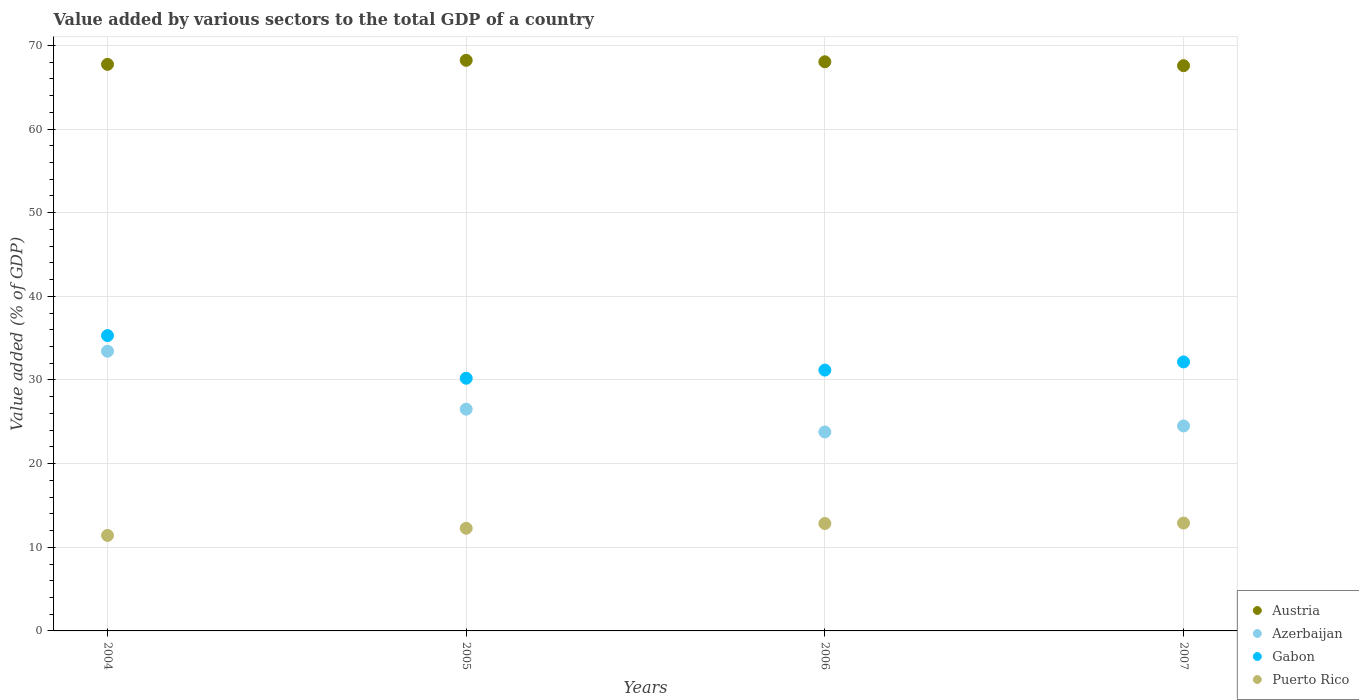How many different coloured dotlines are there?
Your response must be concise. 4. Is the number of dotlines equal to the number of legend labels?
Provide a succinct answer. Yes. What is the value added by various sectors to the total GDP in Azerbaijan in 2004?
Ensure brevity in your answer.  33.44. Across all years, what is the maximum value added by various sectors to the total GDP in Puerto Rico?
Keep it short and to the point. 12.9. Across all years, what is the minimum value added by various sectors to the total GDP in Puerto Rico?
Your answer should be compact. 11.42. What is the total value added by various sectors to the total GDP in Puerto Rico in the graph?
Offer a terse response. 49.43. What is the difference between the value added by various sectors to the total GDP in Puerto Rico in 2005 and that in 2007?
Keep it short and to the point. -0.62. What is the difference between the value added by various sectors to the total GDP in Azerbaijan in 2005 and the value added by various sectors to the total GDP in Gabon in 2007?
Your response must be concise. -5.65. What is the average value added by various sectors to the total GDP in Puerto Rico per year?
Keep it short and to the point. 12.36. In the year 2006, what is the difference between the value added by various sectors to the total GDP in Austria and value added by various sectors to the total GDP in Gabon?
Offer a very short reply. 36.86. In how many years, is the value added by various sectors to the total GDP in Puerto Rico greater than 62 %?
Offer a very short reply. 0. What is the ratio of the value added by various sectors to the total GDP in Austria in 2004 to that in 2006?
Keep it short and to the point. 1. Is the value added by various sectors to the total GDP in Azerbaijan in 2005 less than that in 2007?
Your response must be concise. No. Is the difference between the value added by various sectors to the total GDP in Austria in 2004 and 2007 greater than the difference between the value added by various sectors to the total GDP in Gabon in 2004 and 2007?
Keep it short and to the point. No. What is the difference between the highest and the second highest value added by various sectors to the total GDP in Austria?
Make the answer very short. 0.17. What is the difference between the highest and the lowest value added by various sectors to the total GDP in Azerbaijan?
Your answer should be compact. 9.65. Is it the case that in every year, the sum of the value added by various sectors to the total GDP in Puerto Rico and value added by various sectors to the total GDP in Azerbaijan  is greater than the value added by various sectors to the total GDP in Gabon?
Offer a very short reply. Yes. Does the value added by various sectors to the total GDP in Puerto Rico monotonically increase over the years?
Your response must be concise. Yes. How many dotlines are there?
Ensure brevity in your answer.  4. How many years are there in the graph?
Provide a short and direct response. 4. What is the difference between two consecutive major ticks on the Y-axis?
Ensure brevity in your answer.  10. Are the values on the major ticks of Y-axis written in scientific E-notation?
Provide a succinct answer. No. Does the graph contain any zero values?
Ensure brevity in your answer.  No. Where does the legend appear in the graph?
Provide a succinct answer. Bottom right. How are the legend labels stacked?
Give a very brief answer. Vertical. What is the title of the graph?
Ensure brevity in your answer.  Value added by various sectors to the total GDP of a country. What is the label or title of the X-axis?
Provide a short and direct response. Years. What is the label or title of the Y-axis?
Your answer should be compact. Value added (% of GDP). What is the Value added (% of GDP) in Austria in 2004?
Your response must be concise. 67.73. What is the Value added (% of GDP) in Azerbaijan in 2004?
Offer a very short reply. 33.44. What is the Value added (% of GDP) in Gabon in 2004?
Provide a succinct answer. 35.3. What is the Value added (% of GDP) in Puerto Rico in 2004?
Your response must be concise. 11.42. What is the Value added (% of GDP) of Austria in 2005?
Your answer should be compact. 68.21. What is the Value added (% of GDP) in Azerbaijan in 2005?
Provide a succinct answer. 26.51. What is the Value added (% of GDP) of Gabon in 2005?
Ensure brevity in your answer.  30.21. What is the Value added (% of GDP) in Puerto Rico in 2005?
Your answer should be very brief. 12.27. What is the Value added (% of GDP) of Austria in 2006?
Provide a short and direct response. 68.04. What is the Value added (% of GDP) of Azerbaijan in 2006?
Your answer should be compact. 23.79. What is the Value added (% of GDP) of Gabon in 2006?
Provide a succinct answer. 31.18. What is the Value added (% of GDP) in Puerto Rico in 2006?
Your answer should be very brief. 12.84. What is the Value added (% of GDP) of Austria in 2007?
Your answer should be compact. 67.57. What is the Value added (% of GDP) in Azerbaijan in 2007?
Provide a short and direct response. 24.5. What is the Value added (% of GDP) in Gabon in 2007?
Ensure brevity in your answer.  32.16. What is the Value added (% of GDP) of Puerto Rico in 2007?
Make the answer very short. 12.9. Across all years, what is the maximum Value added (% of GDP) of Austria?
Ensure brevity in your answer.  68.21. Across all years, what is the maximum Value added (% of GDP) of Azerbaijan?
Provide a short and direct response. 33.44. Across all years, what is the maximum Value added (% of GDP) of Gabon?
Offer a very short reply. 35.3. Across all years, what is the maximum Value added (% of GDP) of Puerto Rico?
Make the answer very short. 12.9. Across all years, what is the minimum Value added (% of GDP) of Austria?
Your answer should be compact. 67.57. Across all years, what is the minimum Value added (% of GDP) in Azerbaijan?
Your response must be concise. 23.79. Across all years, what is the minimum Value added (% of GDP) in Gabon?
Give a very brief answer. 30.21. Across all years, what is the minimum Value added (% of GDP) in Puerto Rico?
Provide a short and direct response. 11.42. What is the total Value added (% of GDP) in Austria in the graph?
Provide a succinct answer. 271.56. What is the total Value added (% of GDP) in Azerbaijan in the graph?
Provide a short and direct response. 108.24. What is the total Value added (% of GDP) in Gabon in the graph?
Keep it short and to the point. 128.85. What is the total Value added (% of GDP) of Puerto Rico in the graph?
Your response must be concise. 49.43. What is the difference between the Value added (% of GDP) of Austria in 2004 and that in 2005?
Keep it short and to the point. -0.48. What is the difference between the Value added (% of GDP) in Azerbaijan in 2004 and that in 2005?
Provide a short and direct response. 6.93. What is the difference between the Value added (% of GDP) of Gabon in 2004 and that in 2005?
Keep it short and to the point. 5.1. What is the difference between the Value added (% of GDP) in Puerto Rico in 2004 and that in 2005?
Keep it short and to the point. -0.86. What is the difference between the Value added (% of GDP) in Austria in 2004 and that in 2006?
Keep it short and to the point. -0.31. What is the difference between the Value added (% of GDP) of Azerbaijan in 2004 and that in 2006?
Offer a terse response. 9.65. What is the difference between the Value added (% of GDP) in Gabon in 2004 and that in 2006?
Give a very brief answer. 4.12. What is the difference between the Value added (% of GDP) of Puerto Rico in 2004 and that in 2006?
Your response must be concise. -1.42. What is the difference between the Value added (% of GDP) of Austria in 2004 and that in 2007?
Your answer should be very brief. 0.16. What is the difference between the Value added (% of GDP) in Azerbaijan in 2004 and that in 2007?
Keep it short and to the point. 8.93. What is the difference between the Value added (% of GDP) in Gabon in 2004 and that in 2007?
Offer a very short reply. 3.15. What is the difference between the Value added (% of GDP) of Puerto Rico in 2004 and that in 2007?
Your response must be concise. -1.48. What is the difference between the Value added (% of GDP) in Austria in 2005 and that in 2006?
Provide a short and direct response. 0.17. What is the difference between the Value added (% of GDP) of Azerbaijan in 2005 and that in 2006?
Offer a very short reply. 2.72. What is the difference between the Value added (% of GDP) of Gabon in 2005 and that in 2006?
Keep it short and to the point. -0.97. What is the difference between the Value added (% of GDP) in Puerto Rico in 2005 and that in 2006?
Your response must be concise. -0.57. What is the difference between the Value added (% of GDP) of Austria in 2005 and that in 2007?
Make the answer very short. 0.64. What is the difference between the Value added (% of GDP) in Azerbaijan in 2005 and that in 2007?
Your answer should be very brief. 2.01. What is the difference between the Value added (% of GDP) in Gabon in 2005 and that in 2007?
Offer a terse response. -1.95. What is the difference between the Value added (% of GDP) of Puerto Rico in 2005 and that in 2007?
Provide a short and direct response. -0.62. What is the difference between the Value added (% of GDP) of Austria in 2006 and that in 2007?
Ensure brevity in your answer.  0.47. What is the difference between the Value added (% of GDP) in Azerbaijan in 2006 and that in 2007?
Offer a terse response. -0.72. What is the difference between the Value added (% of GDP) in Gabon in 2006 and that in 2007?
Make the answer very short. -0.98. What is the difference between the Value added (% of GDP) of Puerto Rico in 2006 and that in 2007?
Offer a terse response. -0.06. What is the difference between the Value added (% of GDP) in Austria in 2004 and the Value added (% of GDP) in Azerbaijan in 2005?
Provide a succinct answer. 41.22. What is the difference between the Value added (% of GDP) in Austria in 2004 and the Value added (% of GDP) in Gabon in 2005?
Offer a terse response. 37.52. What is the difference between the Value added (% of GDP) in Austria in 2004 and the Value added (% of GDP) in Puerto Rico in 2005?
Your answer should be very brief. 55.46. What is the difference between the Value added (% of GDP) of Azerbaijan in 2004 and the Value added (% of GDP) of Gabon in 2005?
Keep it short and to the point. 3.23. What is the difference between the Value added (% of GDP) in Azerbaijan in 2004 and the Value added (% of GDP) in Puerto Rico in 2005?
Offer a very short reply. 21.16. What is the difference between the Value added (% of GDP) in Gabon in 2004 and the Value added (% of GDP) in Puerto Rico in 2005?
Give a very brief answer. 23.03. What is the difference between the Value added (% of GDP) in Austria in 2004 and the Value added (% of GDP) in Azerbaijan in 2006?
Make the answer very short. 43.95. What is the difference between the Value added (% of GDP) of Austria in 2004 and the Value added (% of GDP) of Gabon in 2006?
Your answer should be compact. 36.55. What is the difference between the Value added (% of GDP) in Austria in 2004 and the Value added (% of GDP) in Puerto Rico in 2006?
Provide a short and direct response. 54.89. What is the difference between the Value added (% of GDP) of Azerbaijan in 2004 and the Value added (% of GDP) of Gabon in 2006?
Your answer should be compact. 2.26. What is the difference between the Value added (% of GDP) of Azerbaijan in 2004 and the Value added (% of GDP) of Puerto Rico in 2006?
Offer a terse response. 20.6. What is the difference between the Value added (% of GDP) of Gabon in 2004 and the Value added (% of GDP) of Puerto Rico in 2006?
Offer a very short reply. 22.46. What is the difference between the Value added (% of GDP) in Austria in 2004 and the Value added (% of GDP) in Azerbaijan in 2007?
Provide a short and direct response. 43.23. What is the difference between the Value added (% of GDP) of Austria in 2004 and the Value added (% of GDP) of Gabon in 2007?
Provide a short and direct response. 35.58. What is the difference between the Value added (% of GDP) in Austria in 2004 and the Value added (% of GDP) in Puerto Rico in 2007?
Ensure brevity in your answer.  54.84. What is the difference between the Value added (% of GDP) in Azerbaijan in 2004 and the Value added (% of GDP) in Gabon in 2007?
Make the answer very short. 1.28. What is the difference between the Value added (% of GDP) in Azerbaijan in 2004 and the Value added (% of GDP) in Puerto Rico in 2007?
Offer a very short reply. 20.54. What is the difference between the Value added (% of GDP) of Gabon in 2004 and the Value added (% of GDP) of Puerto Rico in 2007?
Give a very brief answer. 22.41. What is the difference between the Value added (% of GDP) of Austria in 2005 and the Value added (% of GDP) of Azerbaijan in 2006?
Provide a short and direct response. 44.43. What is the difference between the Value added (% of GDP) of Austria in 2005 and the Value added (% of GDP) of Gabon in 2006?
Your answer should be very brief. 37.03. What is the difference between the Value added (% of GDP) in Austria in 2005 and the Value added (% of GDP) in Puerto Rico in 2006?
Give a very brief answer. 55.37. What is the difference between the Value added (% of GDP) in Azerbaijan in 2005 and the Value added (% of GDP) in Gabon in 2006?
Your response must be concise. -4.67. What is the difference between the Value added (% of GDP) of Azerbaijan in 2005 and the Value added (% of GDP) of Puerto Rico in 2006?
Make the answer very short. 13.67. What is the difference between the Value added (% of GDP) of Gabon in 2005 and the Value added (% of GDP) of Puerto Rico in 2006?
Your answer should be very brief. 17.37. What is the difference between the Value added (% of GDP) of Austria in 2005 and the Value added (% of GDP) of Azerbaijan in 2007?
Your answer should be compact. 43.71. What is the difference between the Value added (% of GDP) in Austria in 2005 and the Value added (% of GDP) in Gabon in 2007?
Provide a short and direct response. 36.06. What is the difference between the Value added (% of GDP) in Austria in 2005 and the Value added (% of GDP) in Puerto Rico in 2007?
Give a very brief answer. 55.32. What is the difference between the Value added (% of GDP) of Azerbaijan in 2005 and the Value added (% of GDP) of Gabon in 2007?
Keep it short and to the point. -5.65. What is the difference between the Value added (% of GDP) in Azerbaijan in 2005 and the Value added (% of GDP) in Puerto Rico in 2007?
Your response must be concise. 13.61. What is the difference between the Value added (% of GDP) of Gabon in 2005 and the Value added (% of GDP) of Puerto Rico in 2007?
Make the answer very short. 17.31. What is the difference between the Value added (% of GDP) of Austria in 2006 and the Value added (% of GDP) of Azerbaijan in 2007?
Your response must be concise. 43.54. What is the difference between the Value added (% of GDP) in Austria in 2006 and the Value added (% of GDP) in Gabon in 2007?
Make the answer very short. 35.88. What is the difference between the Value added (% of GDP) in Austria in 2006 and the Value added (% of GDP) in Puerto Rico in 2007?
Keep it short and to the point. 55.14. What is the difference between the Value added (% of GDP) of Azerbaijan in 2006 and the Value added (% of GDP) of Gabon in 2007?
Offer a terse response. -8.37. What is the difference between the Value added (% of GDP) in Azerbaijan in 2006 and the Value added (% of GDP) in Puerto Rico in 2007?
Give a very brief answer. 10.89. What is the difference between the Value added (% of GDP) of Gabon in 2006 and the Value added (% of GDP) of Puerto Rico in 2007?
Your answer should be very brief. 18.29. What is the average Value added (% of GDP) in Austria per year?
Ensure brevity in your answer.  67.89. What is the average Value added (% of GDP) of Azerbaijan per year?
Give a very brief answer. 27.06. What is the average Value added (% of GDP) in Gabon per year?
Your answer should be very brief. 32.21. What is the average Value added (% of GDP) in Puerto Rico per year?
Make the answer very short. 12.36. In the year 2004, what is the difference between the Value added (% of GDP) in Austria and Value added (% of GDP) in Azerbaijan?
Offer a terse response. 34.29. In the year 2004, what is the difference between the Value added (% of GDP) of Austria and Value added (% of GDP) of Gabon?
Ensure brevity in your answer.  32.43. In the year 2004, what is the difference between the Value added (% of GDP) in Austria and Value added (% of GDP) in Puerto Rico?
Your response must be concise. 56.32. In the year 2004, what is the difference between the Value added (% of GDP) of Azerbaijan and Value added (% of GDP) of Gabon?
Ensure brevity in your answer.  -1.87. In the year 2004, what is the difference between the Value added (% of GDP) of Azerbaijan and Value added (% of GDP) of Puerto Rico?
Keep it short and to the point. 22.02. In the year 2004, what is the difference between the Value added (% of GDP) in Gabon and Value added (% of GDP) in Puerto Rico?
Make the answer very short. 23.89. In the year 2005, what is the difference between the Value added (% of GDP) of Austria and Value added (% of GDP) of Azerbaijan?
Your response must be concise. 41.7. In the year 2005, what is the difference between the Value added (% of GDP) in Austria and Value added (% of GDP) in Gabon?
Offer a terse response. 38. In the year 2005, what is the difference between the Value added (% of GDP) of Austria and Value added (% of GDP) of Puerto Rico?
Keep it short and to the point. 55.94. In the year 2005, what is the difference between the Value added (% of GDP) of Azerbaijan and Value added (% of GDP) of Gabon?
Offer a terse response. -3.7. In the year 2005, what is the difference between the Value added (% of GDP) in Azerbaijan and Value added (% of GDP) in Puerto Rico?
Give a very brief answer. 14.24. In the year 2005, what is the difference between the Value added (% of GDP) in Gabon and Value added (% of GDP) in Puerto Rico?
Offer a very short reply. 17.93. In the year 2006, what is the difference between the Value added (% of GDP) of Austria and Value added (% of GDP) of Azerbaijan?
Ensure brevity in your answer.  44.25. In the year 2006, what is the difference between the Value added (% of GDP) in Austria and Value added (% of GDP) in Gabon?
Your answer should be compact. 36.86. In the year 2006, what is the difference between the Value added (% of GDP) of Austria and Value added (% of GDP) of Puerto Rico?
Offer a terse response. 55.2. In the year 2006, what is the difference between the Value added (% of GDP) of Azerbaijan and Value added (% of GDP) of Gabon?
Keep it short and to the point. -7.4. In the year 2006, what is the difference between the Value added (% of GDP) of Azerbaijan and Value added (% of GDP) of Puerto Rico?
Offer a very short reply. 10.95. In the year 2006, what is the difference between the Value added (% of GDP) in Gabon and Value added (% of GDP) in Puerto Rico?
Offer a very short reply. 18.34. In the year 2007, what is the difference between the Value added (% of GDP) of Austria and Value added (% of GDP) of Azerbaijan?
Give a very brief answer. 43.07. In the year 2007, what is the difference between the Value added (% of GDP) of Austria and Value added (% of GDP) of Gabon?
Make the answer very short. 35.42. In the year 2007, what is the difference between the Value added (% of GDP) of Austria and Value added (% of GDP) of Puerto Rico?
Keep it short and to the point. 54.68. In the year 2007, what is the difference between the Value added (% of GDP) of Azerbaijan and Value added (% of GDP) of Gabon?
Keep it short and to the point. -7.65. In the year 2007, what is the difference between the Value added (% of GDP) in Azerbaijan and Value added (% of GDP) in Puerto Rico?
Your response must be concise. 11.61. In the year 2007, what is the difference between the Value added (% of GDP) in Gabon and Value added (% of GDP) in Puerto Rico?
Give a very brief answer. 19.26. What is the ratio of the Value added (% of GDP) of Azerbaijan in 2004 to that in 2005?
Your answer should be very brief. 1.26. What is the ratio of the Value added (% of GDP) of Gabon in 2004 to that in 2005?
Provide a succinct answer. 1.17. What is the ratio of the Value added (% of GDP) of Puerto Rico in 2004 to that in 2005?
Keep it short and to the point. 0.93. What is the ratio of the Value added (% of GDP) of Azerbaijan in 2004 to that in 2006?
Your answer should be compact. 1.41. What is the ratio of the Value added (% of GDP) of Gabon in 2004 to that in 2006?
Give a very brief answer. 1.13. What is the ratio of the Value added (% of GDP) of Puerto Rico in 2004 to that in 2006?
Your answer should be compact. 0.89. What is the ratio of the Value added (% of GDP) of Austria in 2004 to that in 2007?
Your response must be concise. 1. What is the ratio of the Value added (% of GDP) in Azerbaijan in 2004 to that in 2007?
Provide a short and direct response. 1.36. What is the ratio of the Value added (% of GDP) of Gabon in 2004 to that in 2007?
Provide a succinct answer. 1.1. What is the ratio of the Value added (% of GDP) in Puerto Rico in 2004 to that in 2007?
Offer a terse response. 0.89. What is the ratio of the Value added (% of GDP) in Austria in 2005 to that in 2006?
Offer a very short reply. 1. What is the ratio of the Value added (% of GDP) of Azerbaijan in 2005 to that in 2006?
Your response must be concise. 1.11. What is the ratio of the Value added (% of GDP) in Gabon in 2005 to that in 2006?
Provide a succinct answer. 0.97. What is the ratio of the Value added (% of GDP) of Puerto Rico in 2005 to that in 2006?
Offer a very short reply. 0.96. What is the ratio of the Value added (% of GDP) of Austria in 2005 to that in 2007?
Provide a short and direct response. 1.01. What is the ratio of the Value added (% of GDP) of Azerbaijan in 2005 to that in 2007?
Keep it short and to the point. 1.08. What is the ratio of the Value added (% of GDP) in Gabon in 2005 to that in 2007?
Keep it short and to the point. 0.94. What is the ratio of the Value added (% of GDP) in Puerto Rico in 2005 to that in 2007?
Your answer should be compact. 0.95. What is the ratio of the Value added (% of GDP) in Azerbaijan in 2006 to that in 2007?
Provide a short and direct response. 0.97. What is the ratio of the Value added (% of GDP) in Gabon in 2006 to that in 2007?
Offer a very short reply. 0.97. What is the difference between the highest and the second highest Value added (% of GDP) in Austria?
Provide a succinct answer. 0.17. What is the difference between the highest and the second highest Value added (% of GDP) in Azerbaijan?
Give a very brief answer. 6.93. What is the difference between the highest and the second highest Value added (% of GDP) of Gabon?
Keep it short and to the point. 3.15. What is the difference between the highest and the second highest Value added (% of GDP) in Puerto Rico?
Make the answer very short. 0.06. What is the difference between the highest and the lowest Value added (% of GDP) of Austria?
Your answer should be compact. 0.64. What is the difference between the highest and the lowest Value added (% of GDP) of Azerbaijan?
Give a very brief answer. 9.65. What is the difference between the highest and the lowest Value added (% of GDP) in Gabon?
Your answer should be very brief. 5.1. What is the difference between the highest and the lowest Value added (% of GDP) in Puerto Rico?
Provide a short and direct response. 1.48. 